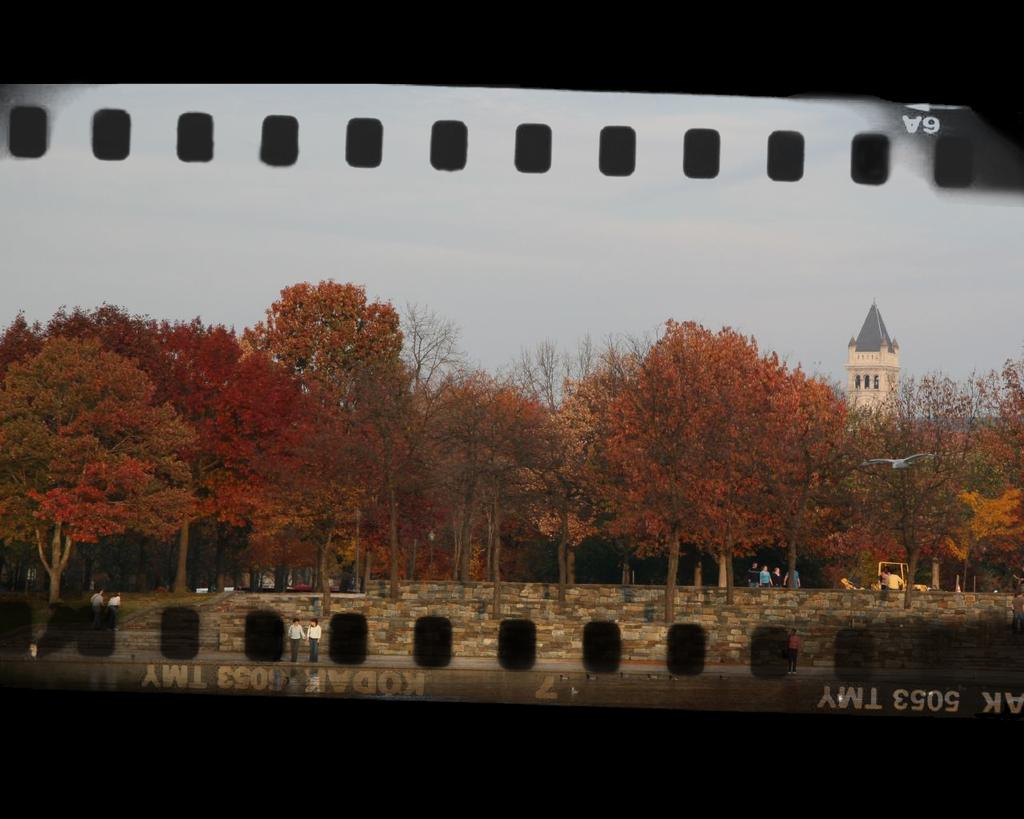<image>
Write a terse but informative summary of the picture. A color photo of a bridge and trees are displayed on Kodak film. 